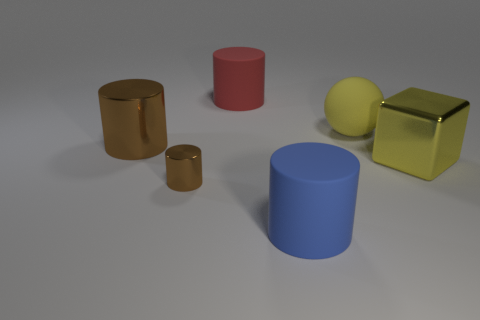What color is the tiny metallic object?
Give a very brief answer. Brown. There is a big cylinder that is behind the big brown object; what material is it?
Your answer should be very brief. Rubber. Are there the same number of brown objects that are in front of the large block and blue cylinders?
Ensure brevity in your answer.  Yes. Is the small brown shiny thing the same shape as the blue rubber thing?
Your response must be concise. Yes. Is there anything else of the same color as the block?
Keep it short and to the point. Yes. The large object that is behind the blue matte cylinder and in front of the large brown shiny cylinder has what shape?
Ensure brevity in your answer.  Cube. Are there the same number of large yellow shiny blocks that are on the right side of the big red rubber thing and metallic cylinders that are left of the big brown metal thing?
Offer a very short reply. No. What number of blocks are either blue objects or small brown objects?
Keep it short and to the point. 0. What number of other big blue cylinders have the same material as the big blue cylinder?
Keep it short and to the point. 0. There is a large rubber thing that is the same color as the cube; what is its shape?
Give a very brief answer. Sphere. 